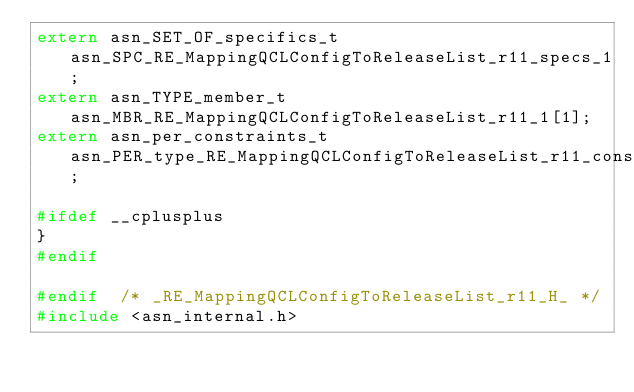<code> <loc_0><loc_0><loc_500><loc_500><_C_>extern asn_SET_OF_specifics_t asn_SPC_RE_MappingQCLConfigToReleaseList_r11_specs_1;
extern asn_TYPE_member_t asn_MBR_RE_MappingQCLConfigToReleaseList_r11_1[1];
extern asn_per_constraints_t asn_PER_type_RE_MappingQCLConfigToReleaseList_r11_constr_1;

#ifdef __cplusplus
}
#endif

#endif	/* _RE_MappingQCLConfigToReleaseList_r11_H_ */
#include <asn_internal.h>
</code> 